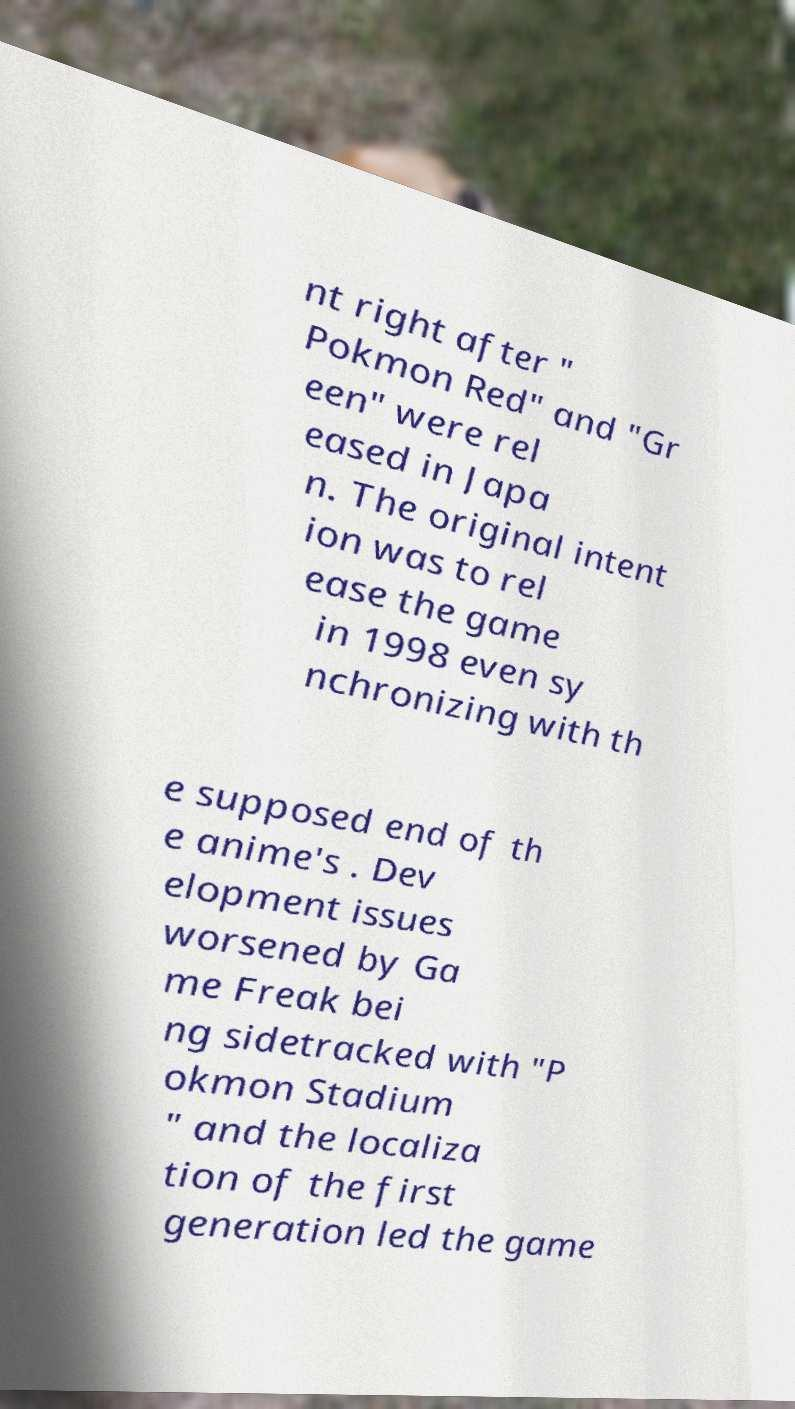There's text embedded in this image that I need extracted. Can you transcribe it verbatim? nt right after " Pokmon Red" and "Gr een" were rel eased in Japa n. The original intent ion was to rel ease the game in 1998 even sy nchronizing with th e supposed end of th e anime's . Dev elopment issues worsened by Ga me Freak bei ng sidetracked with "P okmon Stadium " and the localiza tion of the first generation led the game 